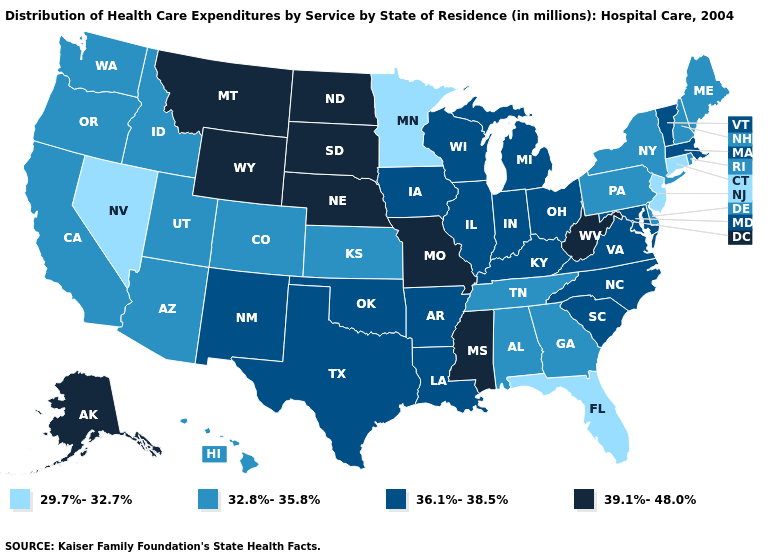Among the states that border Vermont , which have the lowest value?
Be succinct. New Hampshire, New York. Which states hav the highest value in the MidWest?
Be succinct. Missouri, Nebraska, North Dakota, South Dakota. What is the highest value in states that border Vermont?
Write a very short answer. 36.1%-38.5%. What is the lowest value in the Northeast?
Answer briefly. 29.7%-32.7%. What is the value of Mississippi?
Quick response, please. 39.1%-48.0%. Name the states that have a value in the range 32.8%-35.8%?
Keep it brief. Alabama, Arizona, California, Colorado, Delaware, Georgia, Hawaii, Idaho, Kansas, Maine, New Hampshire, New York, Oregon, Pennsylvania, Rhode Island, Tennessee, Utah, Washington. What is the value of Nevada?
Concise answer only. 29.7%-32.7%. Among the states that border Kentucky , does Virginia have the lowest value?
Short answer required. No. What is the highest value in the West ?
Keep it brief. 39.1%-48.0%. Among the states that border Minnesota , which have the lowest value?
Concise answer only. Iowa, Wisconsin. What is the lowest value in the South?
Be succinct. 29.7%-32.7%. What is the value of Florida?
Concise answer only. 29.7%-32.7%. Does the first symbol in the legend represent the smallest category?
Short answer required. Yes. What is the lowest value in states that border Idaho?
Keep it brief. 29.7%-32.7%. What is the value of Tennessee?
Be succinct. 32.8%-35.8%. 